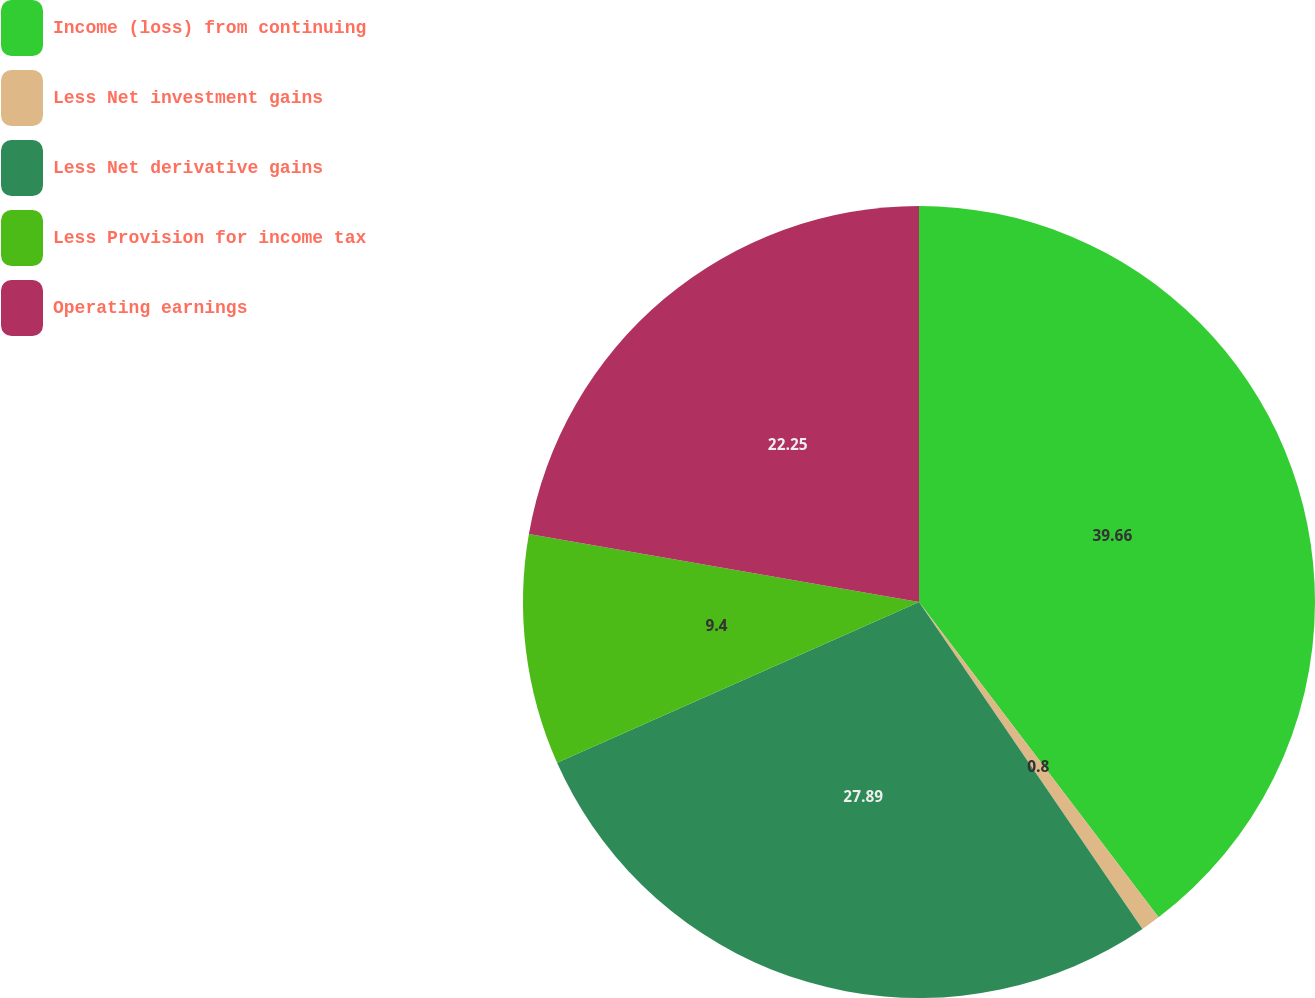<chart> <loc_0><loc_0><loc_500><loc_500><pie_chart><fcel>Income (loss) from continuing<fcel>Less Net investment gains<fcel>Less Net derivative gains<fcel>Less Provision for income tax<fcel>Operating earnings<nl><fcel>39.66%<fcel>0.8%<fcel>27.89%<fcel>9.4%<fcel>22.25%<nl></chart> 